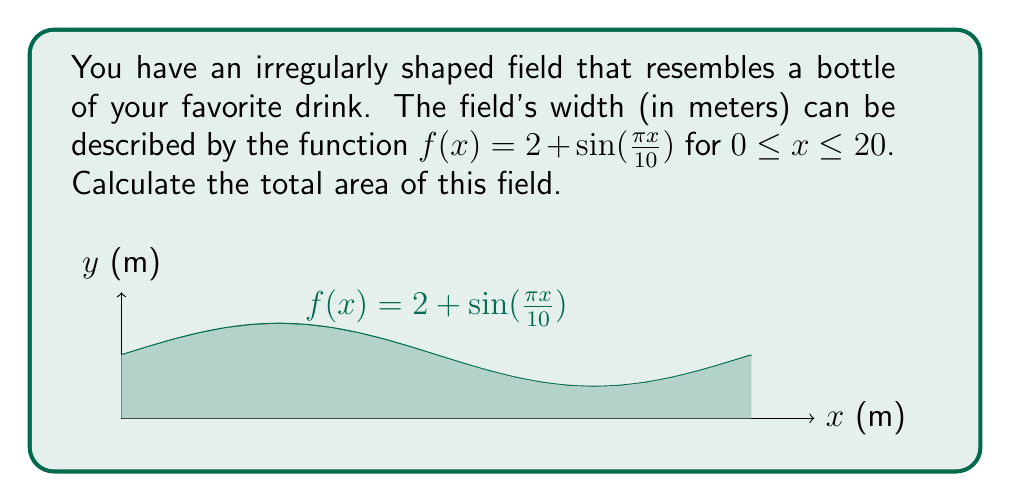Show me your answer to this math problem. To calculate the area of this irregularly shaped field, we need to use integration. The area under a curve $y = f(x)$ from $a$ to $b$ is given by the definite integral:

$$ A = \int_a^b f(x) dx $$

In this case, our function is $f(x) = 2 + \sin(\frac{\pi x}{10})$, and we need to integrate from $x = 0$ to $x = 20$:

$$ A = \int_0^{20} \left(2 + \sin\left(\frac{\pi x}{10}\right)\right) dx $$

Let's break this integral into two parts:

$$ A = \int_0^{20} 2 dx + \int_0^{20} \sin\left(\frac{\pi x}{10}\right) dx $$

For the first part:
$$ \int_0^{20} 2 dx = 2x \bigg|_0^{20} = 40 $$

For the second part, we need to use u-substitution:
Let $u = \frac{\pi x}{10}$, then $du = \frac{\pi}{10} dx$ or $dx = \frac{10}{\pi} du$

When $x = 0$, $u = 0$
When $x = 20$, $u = 2\pi$

$$ \int_0^{20} \sin\left(\frac{\pi x}{10}\right) dx = \frac{10}{\pi} \int_0^{2\pi} \sin(u) du $$

$$ = \frac{10}{\pi} [-\cos(u)]_0^{2\pi} = \frac{10}{\pi} [-\cos(2\pi) + \cos(0)] = 0 $$

Adding the two parts together:

$$ A = 40 + 0 = 40 $$

Therefore, the total area of the field is 40 square meters.
Answer: 40 square meters 